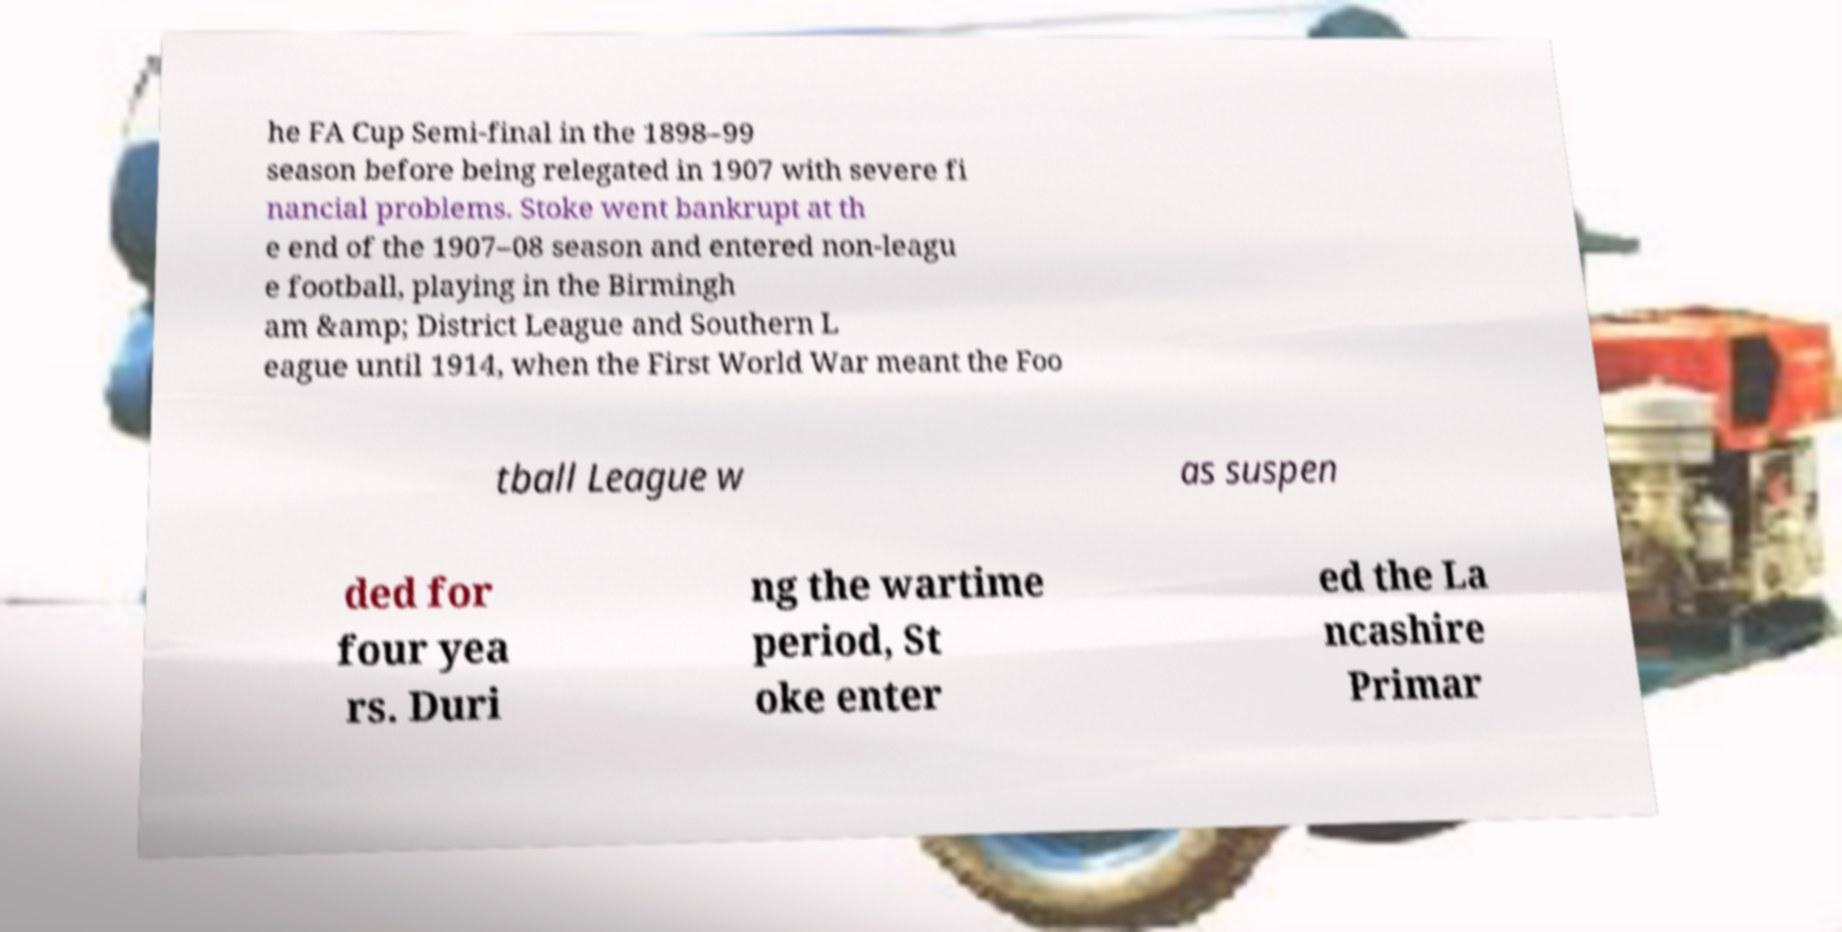Can you accurately transcribe the text from the provided image for me? he FA Cup Semi-final in the 1898–99 season before being relegated in 1907 with severe fi nancial problems. Stoke went bankrupt at th e end of the 1907–08 season and entered non-leagu e football, playing in the Birmingh am &amp; District League and Southern L eague until 1914, when the First World War meant the Foo tball League w as suspen ded for four yea rs. Duri ng the wartime period, St oke enter ed the La ncashire Primar 